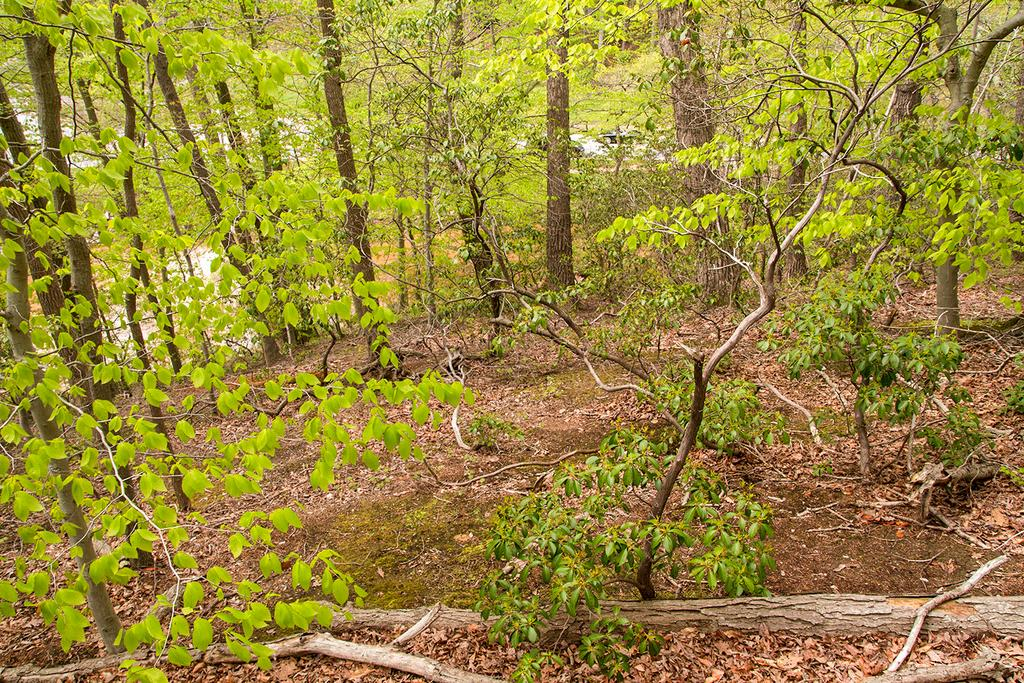What type of vegetation can be seen in the image? There are trees in the image. What is present at the bottom of the image? There is grass at the bottom of the image. What else can be found among the trees and grass in the image? There are leaves in the image. What type of smoke can be seen coming from the girl's hair in the image? There is no girl or smoke present in the image; it features trees, grass, and leaves. 